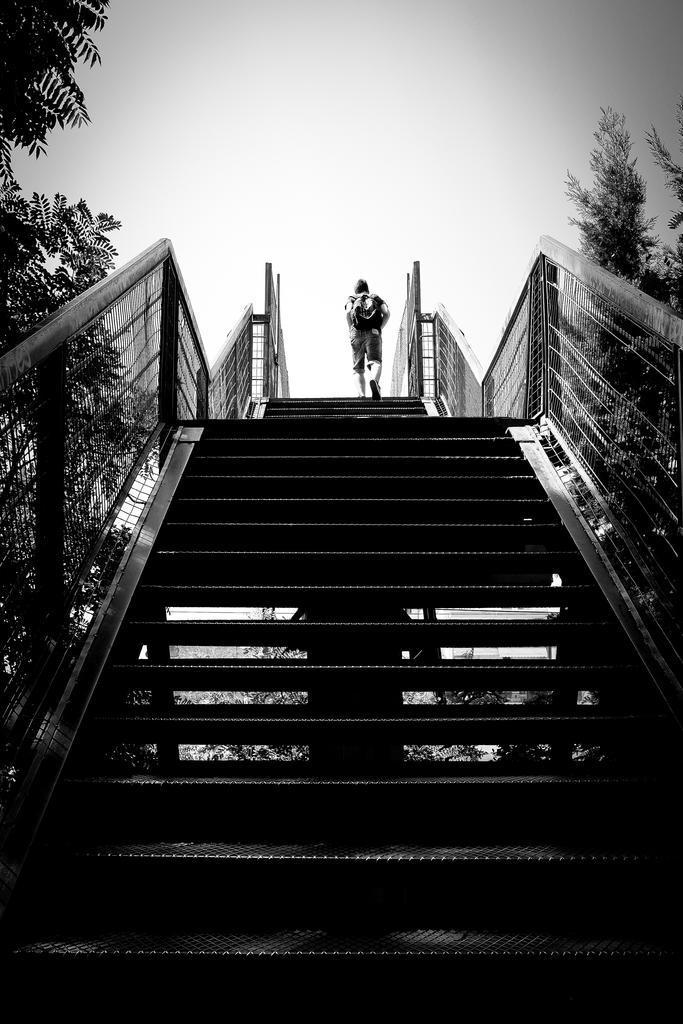What type of architectural feature can be seen in the image? There are steps in the image. What else can be seen in the image besides the steps? There are fences and trees in the image. Is there any sign of human presence in the image? Yes, there is a person in the image. What can be seen in the background of the image? The sky is visible in the background of the image. What type of humor can be seen in the image? There is no humor present in the image; it is a scene with steps, fences, trees, a person, and the sky. Can you see any cats in the image? There are no cats present in the image. 